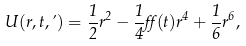<formula> <loc_0><loc_0><loc_500><loc_500>U ( r , t , \varphi ) = \frac { 1 } { 2 } r ^ { 2 } - \frac { 1 } { 4 } \alpha ( t ) r ^ { 4 } + \frac { 1 } { 6 } r ^ { 6 } ,</formula> 